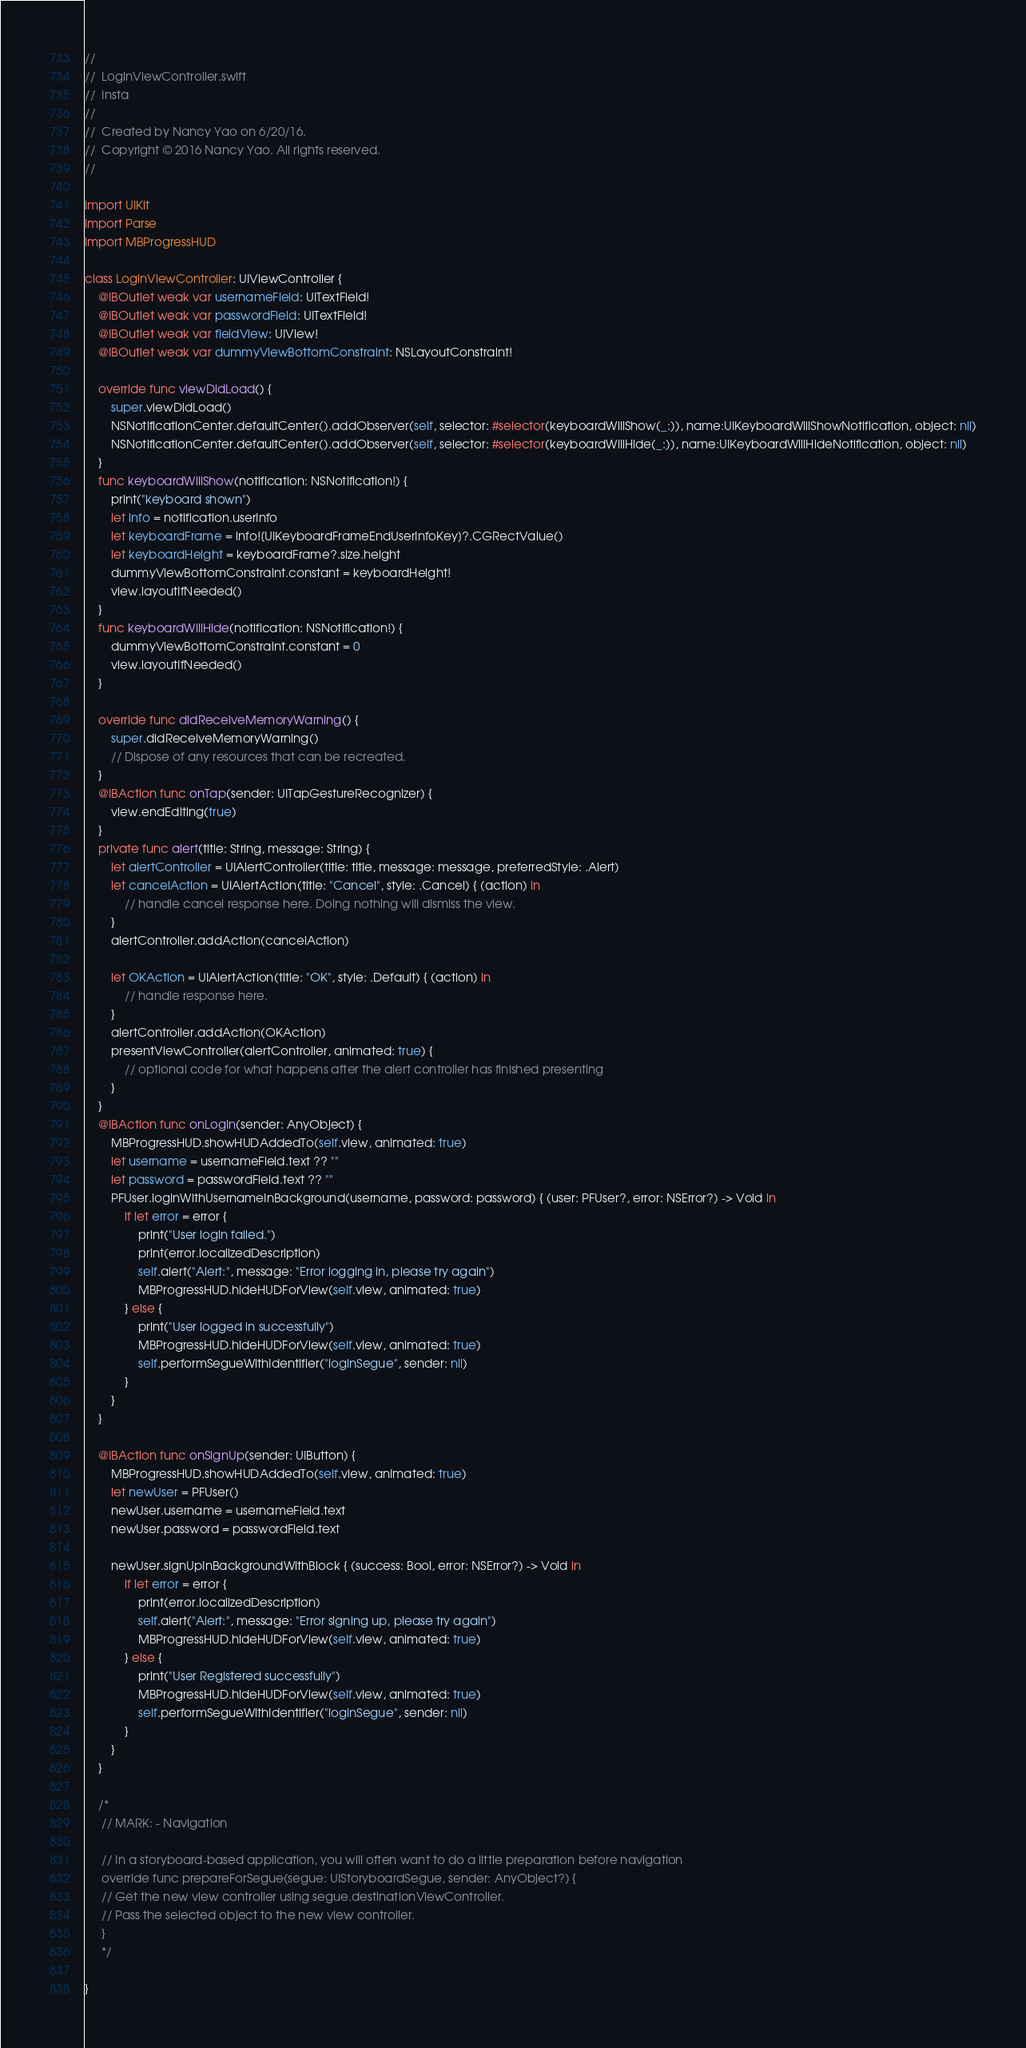<code> <loc_0><loc_0><loc_500><loc_500><_Swift_>//
//  LoginViewController.swift
//  Insta
//
//  Created by Nancy Yao on 6/20/16.
//  Copyright © 2016 Nancy Yao. All rights reserved.
//

import UIKit
import Parse
import MBProgressHUD

class LoginViewController: UIViewController {
    @IBOutlet weak var usernameField: UITextField!
    @IBOutlet weak var passwordField: UITextField!
    @IBOutlet weak var fieldView: UIView!
    @IBOutlet weak var dummyViewBottomConstraint: NSLayoutConstraint!
    
    override func viewDidLoad() {
        super.viewDidLoad()
        NSNotificationCenter.defaultCenter().addObserver(self, selector: #selector(keyboardWillShow(_:)), name:UIKeyboardWillShowNotification, object: nil)
        NSNotificationCenter.defaultCenter().addObserver(self, selector: #selector(keyboardWillHide(_:)), name:UIKeyboardWillHideNotification, object: nil)
    }
    func keyboardWillShow(notification: NSNotification!) {
        print("keyboard shown")
        let info = notification.userInfo
        let keyboardFrame = info![UIKeyboardFrameEndUserInfoKey]?.CGRectValue()
        let keyboardHeight = keyboardFrame?.size.height
        dummyViewBottomConstraint.constant = keyboardHeight!
        view.layoutIfNeeded()
    }
    func keyboardWillHide(notification: NSNotification!) {
        dummyViewBottomConstraint.constant = 0
        view.layoutIfNeeded()
    }
    
    override func didReceiveMemoryWarning() {
        super.didReceiveMemoryWarning()
        // Dispose of any resources that can be recreated.
    }
    @IBAction func onTap(sender: UITapGestureRecognizer) {
        view.endEditing(true)
    }
    private func alert(title: String, message: String) {
        let alertController = UIAlertController(title: title, message: message, preferredStyle: .Alert)
        let cancelAction = UIAlertAction(title: "Cancel", style: .Cancel) { (action) in
            // handle cancel response here. Doing nothing will dismiss the view.
        }
        alertController.addAction(cancelAction)
        
        let OKAction = UIAlertAction(title: "OK", style: .Default) { (action) in
            // handle response here.
        }
        alertController.addAction(OKAction)
        presentViewController(alertController, animated: true) {
            // optional code for what happens after the alert controller has finished presenting
        }
    }
    @IBAction func onLogIn(sender: AnyObject) {
        MBProgressHUD.showHUDAddedTo(self.view, animated: true)
        let username = usernameField.text ?? ""
        let password = passwordField.text ?? ""
        PFUser.logInWithUsernameInBackground(username, password: password) { (user: PFUser?, error: NSError?) -> Void in
            if let error = error {
                print("User login failed.")
                print(error.localizedDescription)
                self.alert("Alert:", message: "Error logging in, please try again")
                MBProgressHUD.hideHUDForView(self.view, animated: true)
            } else {
                print("User logged in successfully")
                MBProgressHUD.hideHUDForView(self.view, animated: true)
                self.performSegueWithIdentifier("loginSegue", sender: nil)
            }
        }
    }
    
    @IBAction func onSignUp(sender: UIButton) {
        MBProgressHUD.showHUDAddedTo(self.view, animated: true)
        let newUser = PFUser()
        newUser.username = usernameField.text
        newUser.password = passwordField.text
        
        newUser.signUpInBackgroundWithBlock { (success: Bool, error: NSError?) -> Void in
            if let error = error {
                print(error.localizedDescription)
                self.alert("Alert:", message: "Error signing up, please try again")
                MBProgressHUD.hideHUDForView(self.view, animated: true)
            } else {
                print("User Registered successfully")
                MBProgressHUD.hideHUDForView(self.view, animated: true)
                self.performSegueWithIdentifier("loginSegue", sender: nil)
            }
        }
    }
    
    /*
     // MARK: - Navigation
     
     // In a storyboard-based application, you will often want to do a little preparation before navigation
     override func prepareForSegue(segue: UIStoryboardSegue, sender: AnyObject?) {
     // Get the new view controller using segue.destinationViewController.
     // Pass the selected object to the new view controller.
     }
     */
    
}
</code> 